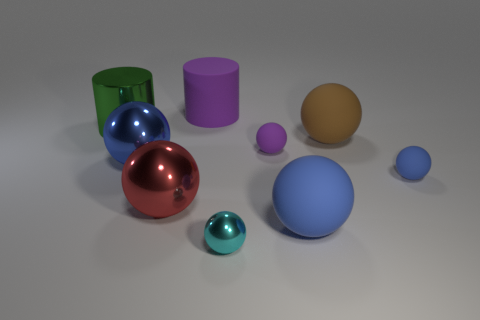Subtract all blue balls. How many were subtracted if there are1blue balls left? 2 Subtract all brown blocks. How many blue spheres are left? 3 Subtract 4 spheres. How many spheres are left? 3 Subtract all purple spheres. How many spheres are left? 6 Subtract all big brown rubber balls. How many balls are left? 6 Subtract all cyan spheres. Subtract all purple cubes. How many spheres are left? 6 Add 1 big red metal balls. How many objects exist? 10 Subtract all cylinders. How many objects are left? 7 Add 2 cyan metallic spheres. How many cyan metallic spheres are left? 3 Add 5 brown shiny cylinders. How many brown shiny cylinders exist? 5 